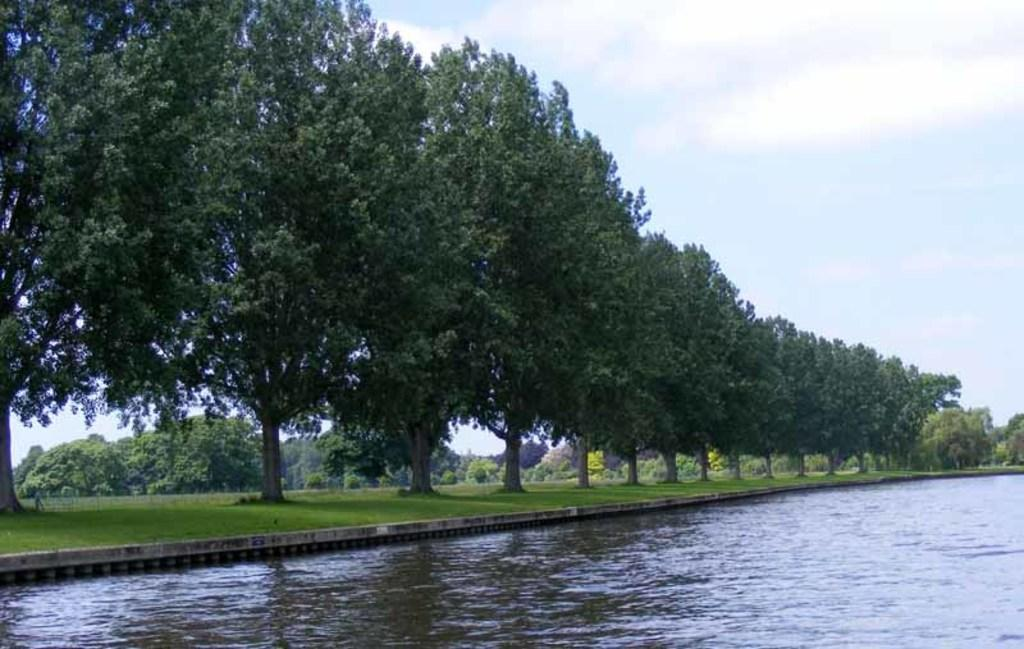What type of vegetation is present in the image? There are many trees in the image. What else can be seen on the ground in the image? There is grass in the image. What is visible at the bottom of the image? There is water visible at the bottom of the image. What can be seen in the background of the image? The background of the image includes water. What type of distribution system is present in the image? There is no distribution system present in the image; it primarily features trees, grass, and water. 